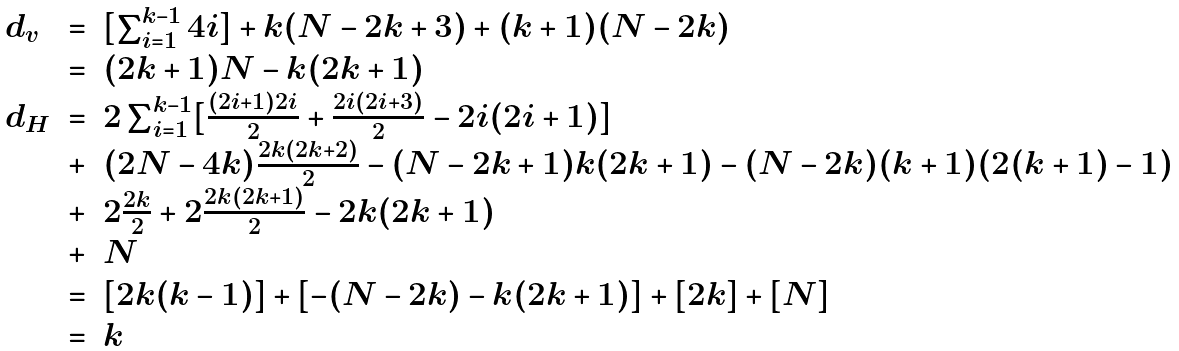<formula> <loc_0><loc_0><loc_500><loc_500>\begin{array} { l l l } d _ { v } & = & [ \sum _ { i = 1 } ^ { k - 1 } 4 i ] + k ( N - 2 k + 3 ) + ( k + 1 ) ( N - 2 k ) \\ & = & ( 2 k + 1 ) N - k ( 2 k + 1 ) \\ d _ { H } & = & 2 \sum _ { i = 1 } ^ { k - 1 } [ \frac { ( 2 i + 1 ) 2 i } { 2 } + \frac { 2 i ( 2 i + 3 ) } { 2 } - 2 i ( 2 i + 1 ) ] \\ & + & ( 2 N - 4 k ) \frac { 2 k ( 2 k + 2 ) } { 2 } - ( N - 2 k + 1 ) k ( 2 k + 1 ) - ( N - 2 k ) ( k + 1 ) ( 2 ( k + 1 ) - 1 ) \\ & + & 2 \frac { 2 k } { 2 } + 2 \frac { 2 k ( 2 k + 1 ) } { 2 } - 2 k ( 2 k + 1 ) \\ & + & N \\ & = & [ 2 k ( k - 1 ) ] + [ - ( N - 2 k ) - k ( 2 k + 1 ) ] + [ 2 k ] + [ N ] \\ & = & k \end{array}</formula> 